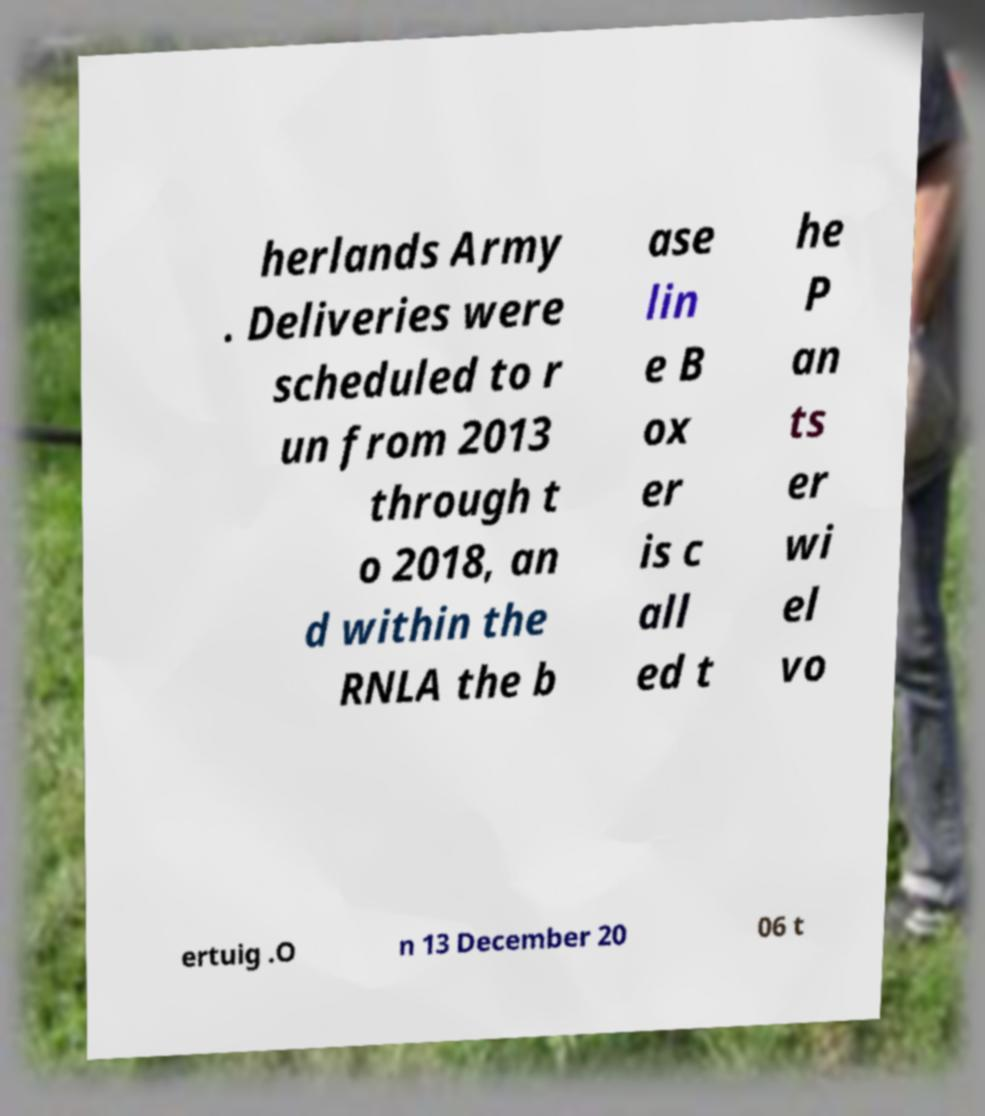Please read and relay the text visible in this image. What does it say? herlands Army . Deliveries were scheduled to r un from 2013 through t o 2018, an d within the RNLA the b ase lin e B ox er is c all ed t he P an ts er wi el vo ertuig .O n 13 December 20 06 t 